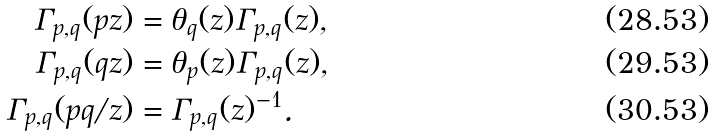<formula> <loc_0><loc_0><loc_500><loc_500>\Gamma _ { p , q } ( p z ) & = \theta _ { q } ( z ) \Gamma _ { p , q } ( z ) , \\ \Gamma _ { p , q } ( q z ) & = \theta _ { p } ( z ) \Gamma _ { p , q } ( z ) , \\ \Gamma _ { p , q } ( p q / z ) & = \Gamma _ { p , q } ( z ) ^ { - 1 } .</formula> 